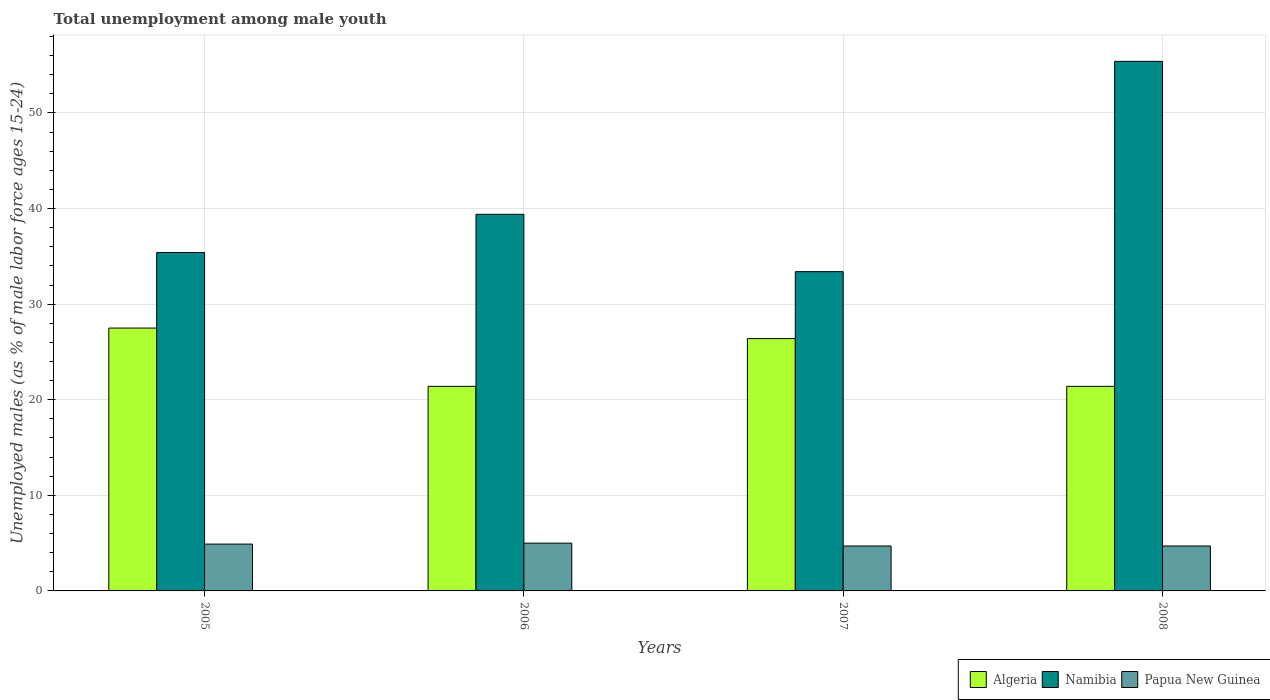Are the number of bars per tick equal to the number of legend labels?
Ensure brevity in your answer.  Yes. What is the label of the 4th group of bars from the left?
Provide a succinct answer. 2008. What is the percentage of unemployed males in in Papua New Guinea in 2008?
Ensure brevity in your answer.  4.7. Across all years, what is the minimum percentage of unemployed males in in Namibia?
Ensure brevity in your answer.  33.4. In which year was the percentage of unemployed males in in Algeria maximum?
Provide a succinct answer. 2005. What is the total percentage of unemployed males in in Papua New Guinea in the graph?
Give a very brief answer. 19.3. What is the difference between the percentage of unemployed males in in Algeria in 2005 and that in 2007?
Your answer should be very brief. 1.1. What is the difference between the percentage of unemployed males in in Namibia in 2007 and the percentage of unemployed males in in Papua New Guinea in 2006?
Keep it short and to the point. 28.4. What is the average percentage of unemployed males in in Namibia per year?
Offer a terse response. 40.9. In the year 2008, what is the difference between the percentage of unemployed males in in Papua New Guinea and percentage of unemployed males in in Namibia?
Your answer should be very brief. -50.7. What is the ratio of the percentage of unemployed males in in Algeria in 2005 to that in 2006?
Your answer should be very brief. 1.29. Is the percentage of unemployed males in in Namibia in 2005 less than that in 2006?
Your response must be concise. Yes. What is the difference between the highest and the second highest percentage of unemployed males in in Papua New Guinea?
Make the answer very short. 0.1. What is the difference between the highest and the lowest percentage of unemployed males in in Algeria?
Ensure brevity in your answer.  6.1. In how many years, is the percentage of unemployed males in in Papua New Guinea greater than the average percentage of unemployed males in in Papua New Guinea taken over all years?
Make the answer very short. 2. Is the sum of the percentage of unemployed males in in Namibia in 2007 and 2008 greater than the maximum percentage of unemployed males in in Papua New Guinea across all years?
Your answer should be very brief. Yes. What does the 2nd bar from the left in 2008 represents?
Offer a terse response. Namibia. What does the 2nd bar from the right in 2008 represents?
Your answer should be very brief. Namibia. How many years are there in the graph?
Provide a succinct answer. 4. What is the difference between two consecutive major ticks on the Y-axis?
Your answer should be compact. 10. Does the graph contain grids?
Your answer should be very brief. Yes. How are the legend labels stacked?
Ensure brevity in your answer.  Horizontal. What is the title of the graph?
Your answer should be compact. Total unemployment among male youth. What is the label or title of the X-axis?
Your answer should be very brief. Years. What is the label or title of the Y-axis?
Provide a succinct answer. Unemployed males (as % of male labor force ages 15-24). What is the Unemployed males (as % of male labor force ages 15-24) in Algeria in 2005?
Your answer should be compact. 27.5. What is the Unemployed males (as % of male labor force ages 15-24) of Namibia in 2005?
Ensure brevity in your answer.  35.4. What is the Unemployed males (as % of male labor force ages 15-24) of Papua New Guinea in 2005?
Ensure brevity in your answer.  4.9. What is the Unemployed males (as % of male labor force ages 15-24) in Algeria in 2006?
Ensure brevity in your answer.  21.4. What is the Unemployed males (as % of male labor force ages 15-24) in Namibia in 2006?
Make the answer very short. 39.4. What is the Unemployed males (as % of male labor force ages 15-24) of Papua New Guinea in 2006?
Your response must be concise. 5. What is the Unemployed males (as % of male labor force ages 15-24) in Algeria in 2007?
Offer a terse response. 26.4. What is the Unemployed males (as % of male labor force ages 15-24) of Namibia in 2007?
Provide a short and direct response. 33.4. What is the Unemployed males (as % of male labor force ages 15-24) of Papua New Guinea in 2007?
Give a very brief answer. 4.7. What is the Unemployed males (as % of male labor force ages 15-24) of Algeria in 2008?
Your response must be concise. 21.4. What is the Unemployed males (as % of male labor force ages 15-24) of Namibia in 2008?
Your answer should be compact. 55.4. What is the Unemployed males (as % of male labor force ages 15-24) of Papua New Guinea in 2008?
Provide a succinct answer. 4.7. Across all years, what is the maximum Unemployed males (as % of male labor force ages 15-24) of Namibia?
Provide a short and direct response. 55.4. Across all years, what is the minimum Unemployed males (as % of male labor force ages 15-24) of Algeria?
Provide a succinct answer. 21.4. Across all years, what is the minimum Unemployed males (as % of male labor force ages 15-24) of Namibia?
Your response must be concise. 33.4. Across all years, what is the minimum Unemployed males (as % of male labor force ages 15-24) in Papua New Guinea?
Your answer should be compact. 4.7. What is the total Unemployed males (as % of male labor force ages 15-24) of Algeria in the graph?
Your response must be concise. 96.7. What is the total Unemployed males (as % of male labor force ages 15-24) in Namibia in the graph?
Offer a very short reply. 163.6. What is the total Unemployed males (as % of male labor force ages 15-24) in Papua New Guinea in the graph?
Make the answer very short. 19.3. What is the difference between the Unemployed males (as % of male labor force ages 15-24) of Algeria in 2005 and that in 2007?
Provide a succinct answer. 1.1. What is the difference between the Unemployed males (as % of male labor force ages 15-24) in Papua New Guinea in 2005 and that in 2007?
Make the answer very short. 0.2. What is the difference between the Unemployed males (as % of male labor force ages 15-24) of Algeria in 2005 and that in 2008?
Offer a terse response. 6.1. What is the difference between the Unemployed males (as % of male labor force ages 15-24) of Namibia in 2005 and that in 2008?
Your answer should be very brief. -20. What is the difference between the Unemployed males (as % of male labor force ages 15-24) of Papua New Guinea in 2006 and that in 2007?
Offer a terse response. 0.3. What is the difference between the Unemployed males (as % of male labor force ages 15-24) in Algeria in 2006 and that in 2008?
Ensure brevity in your answer.  0. What is the difference between the Unemployed males (as % of male labor force ages 15-24) of Namibia in 2006 and that in 2008?
Provide a short and direct response. -16. What is the difference between the Unemployed males (as % of male labor force ages 15-24) of Algeria in 2007 and that in 2008?
Provide a short and direct response. 5. What is the difference between the Unemployed males (as % of male labor force ages 15-24) in Namibia in 2007 and that in 2008?
Keep it short and to the point. -22. What is the difference between the Unemployed males (as % of male labor force ages 15-24) in Papua New Guinea in 2007 and that in 2008?
Your answer should be compact. 0. What is the difference between the Unemployed males (as % of male labor force ages 15-24) in Algeria in 2005 and the Unemployed males (as % of male labor force ages 15-24) in Namibia in 2006?
Make the answer very short. -11.9. What is the difference between the Unemployed males (as % of male labor force ages 15-24) in Algeria in 2005 and the Unemployed males (as % of male labor force ages 15-24) in Papua New Guinea in 2006?
Give a very brief answer. 22.5. What is the difference between the Unemployed males (as % of male labor force ages 15-24) in Namibia in 2005 and the Unemployed males (as % of male labor force ages 15-24) in Papua New Guinea in 2006?
Your answer should be very brief. 30.4. What is the difference between the Unemployed males (as % of male labor force ages 15-24) of Algeria in 2005 and the Unemployed males (as % of male labor force ages 15-24) of Papua New Guinea in 2007?
Make the answer very short. 22.8. What is the difference between the Unemployed males (as % of male labor force ages 15-24) of Namibia in 2005 and the Unemployed males (as % of male labor force ages 15-24) of Papua New Guinea in 2007?
Offer a very short reply. 30.7. What is the difference between the Unemployed males (as % of male labor force ages 15-24) of Algeria in 2005 and the Unemployed males (as % of male labor force ages 15-24) of Namibia in 2008?
Give a very brief answer. -27.9. What is the difference between the Unemployed males (as % of male labor force ages 15-24) in Algeria in 2005 and the Unemployed males (as % of male labor force ages 15-24) in Papua New Guinea in 2008?
Your response must be concise. 22.8. What is the difference between the Unemployed males (as % of male labor force ages 15-24) in Namibia in 2005 and the Unemployed males (as % of male labor force ages 15-24) in Papua New Guinea in 2008?
Your response must be concise. 30.7. What is the difference between the Unemployed males (as % of male labor force ages 15-24) of Namibia in 2006 and the Unemployed males (as % of male labor force ages 15-24) of Papua New Guinea in 2007?
Offer a terse response. 34.7. What is the difference between the Unemployed males (as % of male labor force ages 15-24) in Algeria in 2006 and the Unemployed males (as % of male labor force ages 15-24) in Namibia in 2008?
Make the answer very short. -34. What is the difference between the Unemployed males (as % of male labor force ages 15-24) of Namibia in 2006 and the Unemployed males (as % of male labor force ages 15-24) of Papua New Guinea in 2008?
Provide a succinct answer. 34.7. What is the difference between the Unemployed males (as % of male labor force ages 15-24) in Algeria in 2007 and the Unemployed males (as % of male labor force ages 15-24) in Namibia in 2008?
Keep it short and to the point. -29. What is the difference between the Unemployed males (as % of male labor force ages 15-24) in Algeria in 2007 and the Unemployed males (as % of male labor force ages 15-24) in Papua New Guinea in 2008?
Your answer should be very brief. 21.7. What is the difference between the Unemployed males (as % of male labor force ages 15-24) of Namibia in 2007 and the Unemployed males (as % of male labor force ages 15-24) of Papua New Guinea in 2008?
Offer a terse response. 28.7. What is the average Unemployed males (as % of male labor force ages 15-24) of Algeria per year?
Keep it short and to the point. 24.18. What is the average Unemployed males (as % of male labor force ages 15-24) of Namibia per year?
Your response must be concise. 40.9. What is the average Unemployed males (as % of male labor force ages 15-24) in Papua New Guinea per year?
Ensure brevity in your answer.  4.83. In the year 2005, what is the difference between the Unemployed males (as % of male labor force ages 15-24) in Algeria and Unemployed males (as % of male labor force ages 15-24) in Namibia?
Offer a very short reply. -7.9. In the year 2005, what is the difference between the Unemployed males (as % of male labor force ages 15-24) in Algeria and Unemployed males (as % of male labor force ages 15-24) in Papua New Guinea?
Ensure brevity in your answer.  22.6. In the year 2005, what is the difference between the Unemployed males (as % of male labor force ages 15-24) in Namibia and Unemployed males (as % of male labor force ages 15-24) in Papua New Guinea?
Offer a very short reply. 30.5. In the year 2006, what is the difference between the Unemployed males (as % of male labor force ages 15-24) in Algeria and Unemployed males (as % of male labor force ages 15-24) in Namibia?
Provide a succinct answer. -18. In the year 2006, what is the difference between the Unemployed males (as % of male labor force ages 15-24) in Namibia and Unemployed males (as % of male labor force ages 15-24) in Papua New Guinea?
Give a very brief answer. 34.4. In the year 2007, what is the difference between the Unemployed males (as % of male labor force ages 15-24) of Algeria and Unemployed males (as % of male labor force ages 15-24) of Namibia?
Your answer should be compact. -7. In the year 2007, what is the difference between the Unemployed males (as % of male labor force ages 15-24) of Algeria and Unemployed males (as % of male labor force ages 15-24) of Papua New Guinea?
Ensure brevity in your answer.  21.7. In the year 2007, what is the difference between the Unemployed males (as % of male labor force ages 15-24) in Namibia and Unemployed males (as % of male labor force ages 15-24) in Papua New Guinea?
Keep it short and to the point. 28.7. In the year 2008, what is the difference between the Unemployed males (as % of male labor force ages 15-24) in Algeria and Unemployed males (as % of male labor force ages 15-24) in Namibia?
Offer a terse response. -34. In the year 2008, what is the difference between the Unemployed males (as % of male labor force ages 15-24) of Algeria and Unemployed males (as % of male labor force ages 15-24) of Papua New Guinea?
Ensure brevity in your answer.  16.7. In the year 2008, what is the difference between the Unemployed males (as % of male labor force ages 15-24) of Namibia and Unemployed males (as % of male labor force ages 15-24) of Papua New Guinea?
Offer a very short reply. 50.7. What is the ratio of the Unemployed males (as % of male labor force ages 15-24) of Algeria in 2005 to that in 2006?
Your response must be concise. 1.28. What is the ratio of the Unemployed males (as % of male labor force ages 15-24) in Namibia in 2005 to that in 2006?
Your answer should be compact. 0.9. What is the ratio of the Unemployed males (as % of male labor force ages 15-24) in Papua New Guinea in 2005 to that in 2006?
Your response must be concise. 0.98. What is the ratio of the Unemployed males (as % of male labor force ages 15-24) in Algeria in 2005 to that in 2007?
Give a very brief answer. 1.04. What is the ratio of the Unemployed males (as % of male labor force ages 15-24) of Namibia in 2005 to that in 2007?
Give a very brief answer. 1.06. What is the ratio of the Unemployed males (as % of male labor force ages 15-24) of Papua New Guinea in 2005 to that in 2007?
Keep it short and to the point. 1.04. What is the ratio of the Unemployed males (as % of male labor force ages 15-24) in Algeria in 2005 to that in 2008?
Offer a terse response. 1.28. What is the ratio of the Unemployed males (as % of male labor force ages 15-24) of Namibia in 2005 to that in 2008?
Provide a succinct answer. 0.64. What is the ratio of the Unemployed males (as % of male labor force ages 15-24) of Papua New Guinea in 2005 to that in 2008?
Your answer should be compact. 1.04. What is the ratio of the Unemployed males (as % of male labor force ages 15-24) of Algeria in 2006 to that in 2007?
Your answer should be compact. 0.81. What is the ratio of the Unemployed males (as % of male labor force ages 15-24) of Namibia in 2006 to that in 2007?
Offer a terse response. 1.18. What is the ratio of the Unemployed males (as % of male labor force ages 15-24) in Papua New Guinea in 2006 to that in 2007?
Make the answer very short. 1.06. What is the ratio of the Unemployed males (as % of male labor force ages 15-24) in Algeria in 2006 to that in 2008?
Give a very brief answer. 1. What is the ratio of the Unemployed males (as % of male labor force ages 15-24) of Namibia in 2006 to that in 2008?
Offer a very short reply. 0.71. What is the ratio of the Unemployed males (as % of male labor force ages 15-24) of Papua New Guinea in 2006 to that in 2008?
Your answer should be very brief. 1.06. What is the ratio of the Unemployed males (as % of male labor force ages 15-24) of Algeria in 2007 to that in 2008?
Your response must be concise. 1.23. What is the ratio of the Unemployed males (as % of male labor force ages 15-24) in Namibia in 2007 to that in 2008?
Your answer should be very brief. 0.6. What is the ratio of the Unemployed males (as % of male labor force ages 15-24) in Papua New Guinea in 2007 to that in 2008?
Your answer should be compact. 1. What is the difference between the highest and the second highest Unemployed males (as % of male labor force ages 15-24) in Algeria?
Your answer should be very brief. 1.1. What is the difference between the highest and the second highest Unemployed males (as % of male labor force ages 15-24) in Papua New Guinea?
Provide a short and direct response. 0.1. What is the difference between the highest and the lowest Unemployed males (as % of male labor force ages 15-24) in Algeria?
Give a very brief answer. 6.1. 